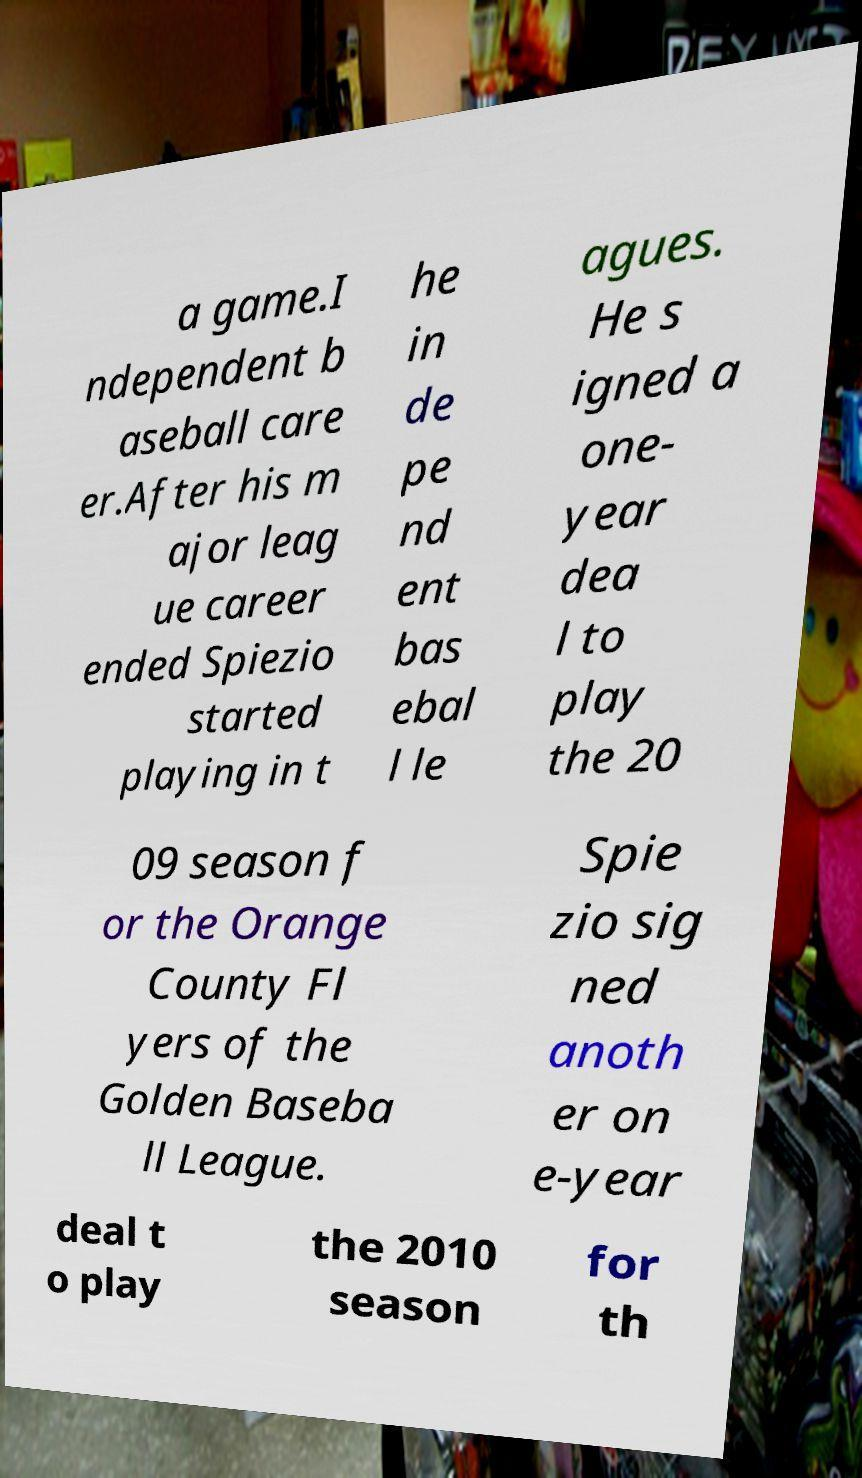Please read and relay the text visible in this image. What does it say? a game.I ndependent b aseball care er.After his m ajor leag ue career ended Spiezio started playing in t he in de pe nd ent bas ebal l le agues. He s igned a one- year dea l to play the 20 09 season f or the Orange County Fl yers of the Golden Baseba ll League. Spie zio sig ned anoth er on e-year deal t o play the 2010 season for th 